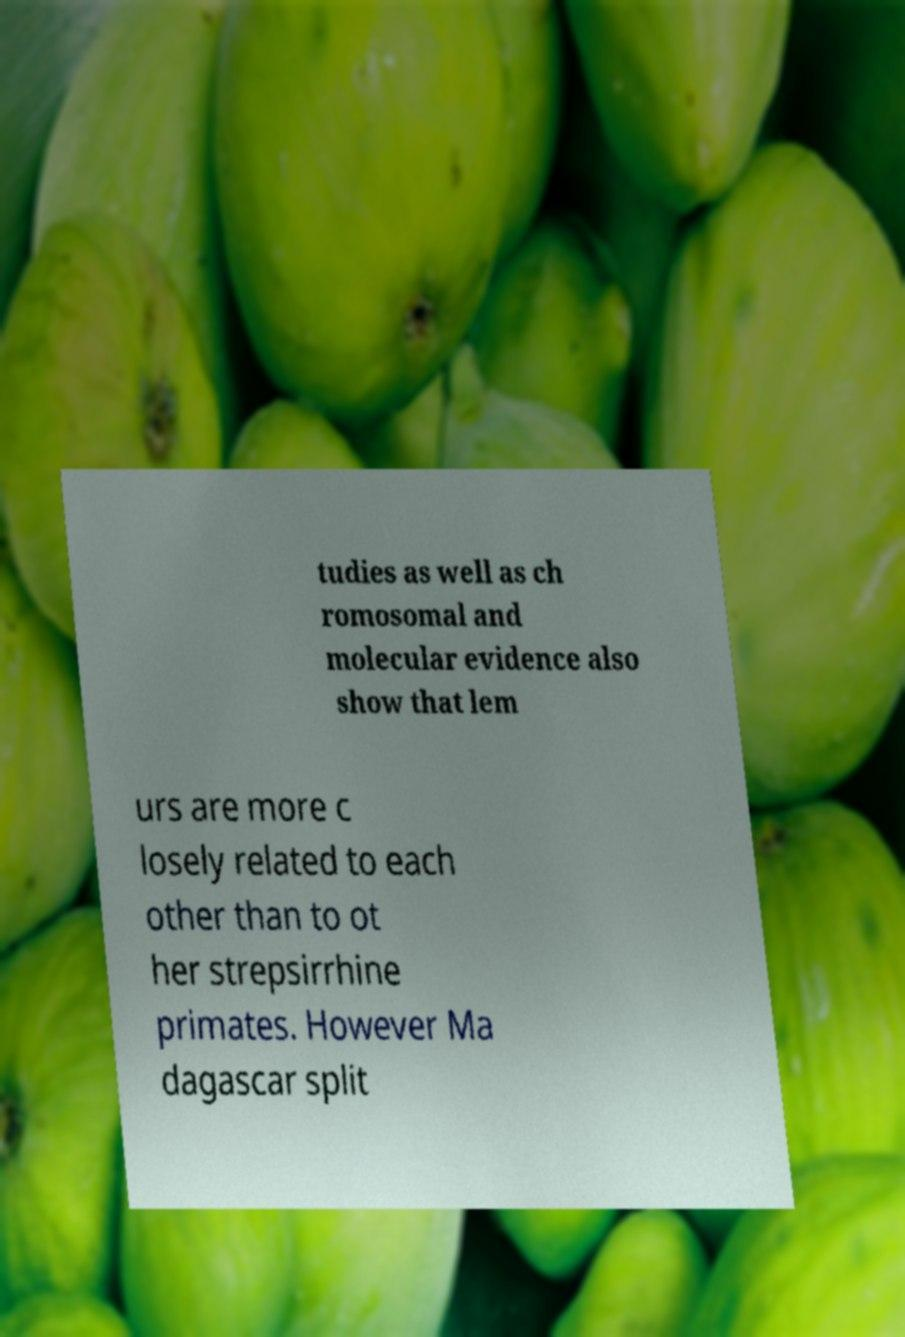Please identify and transcribe the text found in this image. tudies as well as ch romosomal and molecular evidence also show that lem urs are more c losely related to each other than to ot her strepsirrhine primates. However Ma dagascar split 